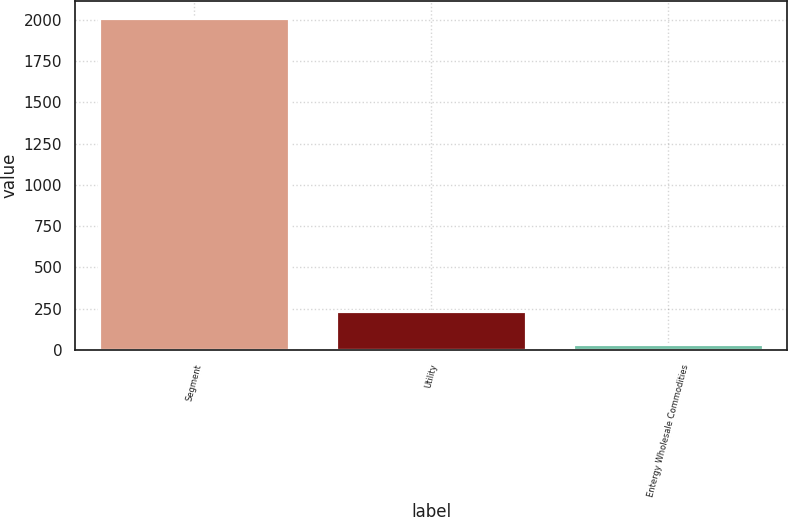Convert chart to OTSL. <chart><loc_0><loc_0><loc_500><loc_500><bar_chart><fcel>Segment<fcel>Utility<fcel>Entergy Wholesale Commodities<nl><fcel>2010<fcel>236.1<fcel>39<nl></chart> 